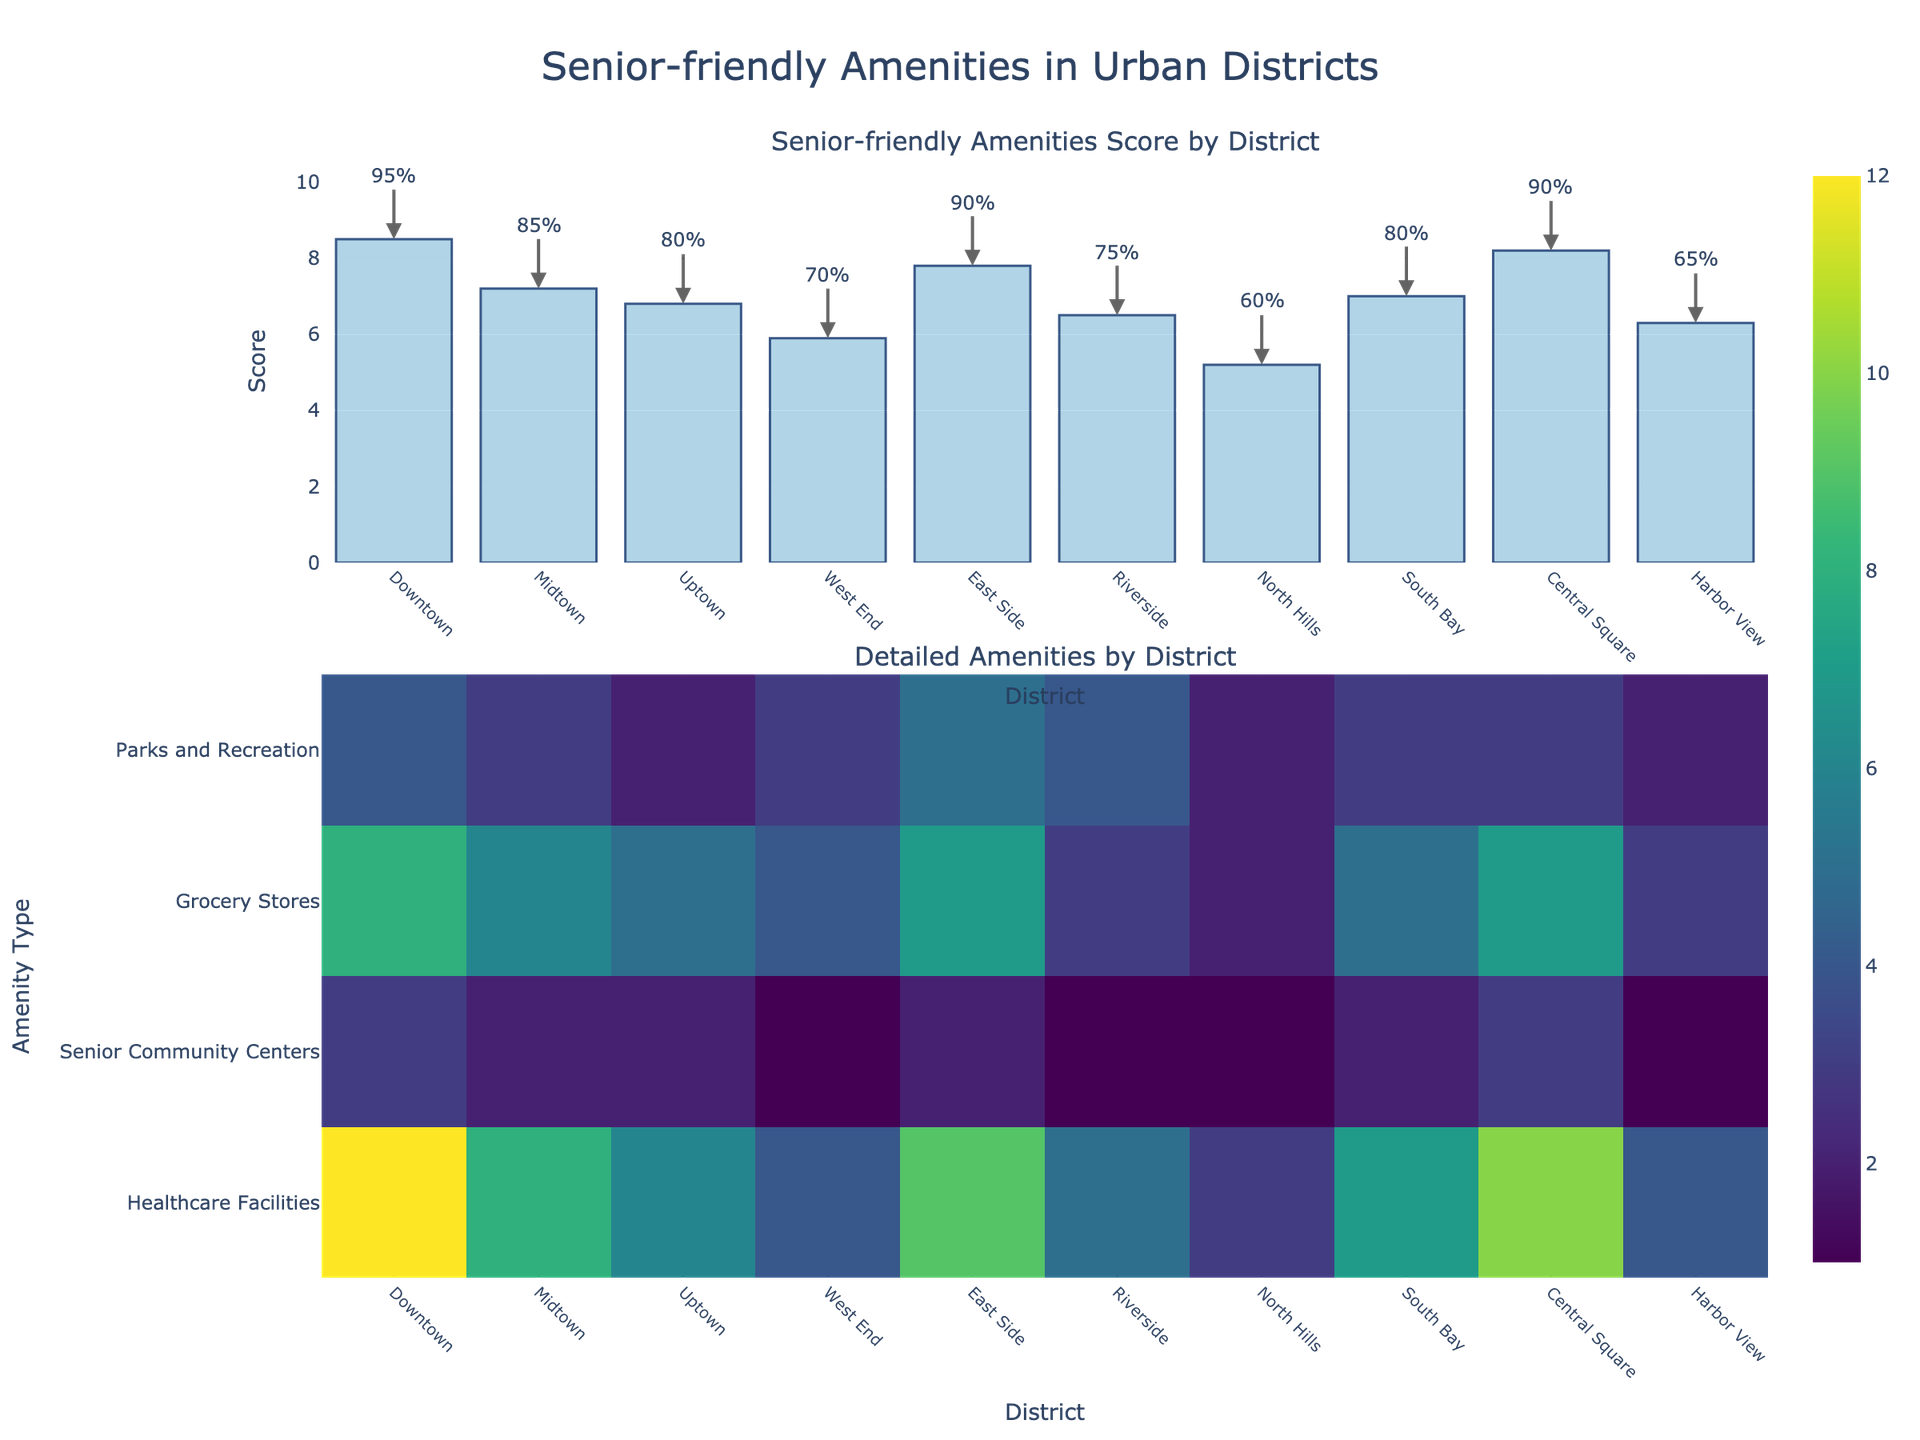What is the title of the figure? The title can be found at the top of the figure in text. It reads, "Senior-friendly Amenities in Urban Districts".
Answer: Senior-friendly Amenities in Urban Districts Which district has the highest Senior-friendly Amenities Score? By looking at the bar chart in the first subplot, Downtown has the tallest bar which represents the highest score.
Answer: Downtown How many Senior Community Centers are there in Riverside? In the heatmap under the row "Senior Community Centers", you find Riverside (x-axis) and read the number at the intersection, which is 1.
Answer: 1 What is the Public Transportation Access percentage in Midtown? Refer to the text annotations above the bar chart for Midtown in the first subplot, it shows "85%".
Answer: 85% Which district has the least number of Healthcare Facilities? In the heatmap row "Healthcare Facilities", the least number observed is 3, which corresponds to North Hills.
Answer: North Hills What districts have exactly 2 Senior Community Centers? In the heatmap row "Senior Community Centers", 2 is observed in Midtown, Uptown, East Side, and South Bay.
Answer: Midtown, Uptown, East Side, South Bay Compare the number of Grocery Stores in Downtown and East Side. Which one has more? In the heatmap row "Grocery Stores", Downtown has 8, and East Side has 7, showing Downtown has more.
Answer: Downtown Which district has the lowest score and still maintains at least 4 Amenities (Healthcare Facilities + Senior Community Centers + Grocery Stores + Parks and Recreation)? Calculate the total non-zero values for the districts and compare their scores. West End meets the condition with a score of 5.9 and has 4 amenities.
Answer: West End What is the average Senior-friendly Amenities Score of districts with more than 90% Public Transportation Access? From annotations, the scores for Downtown and Central Square are 8.5 and 8.2, respectively. Their average is (8.5 + 8.2) / 2 = 8.35.
Answer: 8.35 Between Central Square and South Bay, which district has a better score for Senior-friendly Amenities and by how much? Compare the Senior-friendly Amenities Scores from the bar chart: Central Square has 8.2, South Bay has 7. The difference is 8.2 - 7 = 1.2.
Answer: Central Square, 1.2 